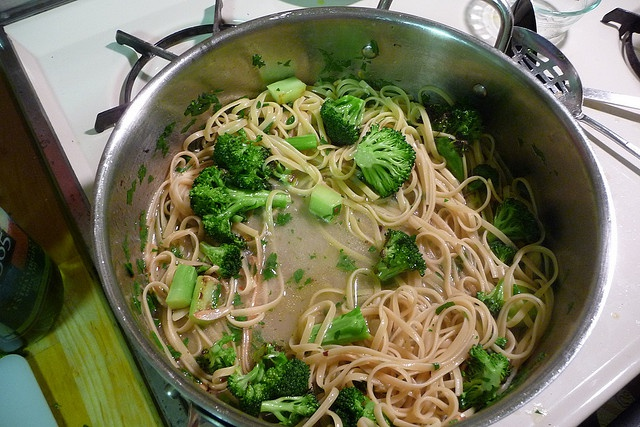Describe the objects in this image and their specific colors. I can see bowl in gray, darkgreen, black, and tan tones, oven in gray, lightgray, black, and darkgray tones, broccoli in gray, black, darkgreen, and green tones, spoon in gray, darkgray, lightgray, and black tones, and broccoli in gray, black, darkgreen, and green tones in this image. 